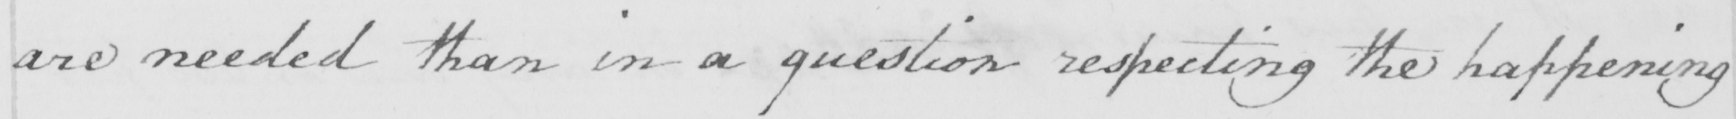What text is written in this handwritten line? are needed than in a question respecting the happening 